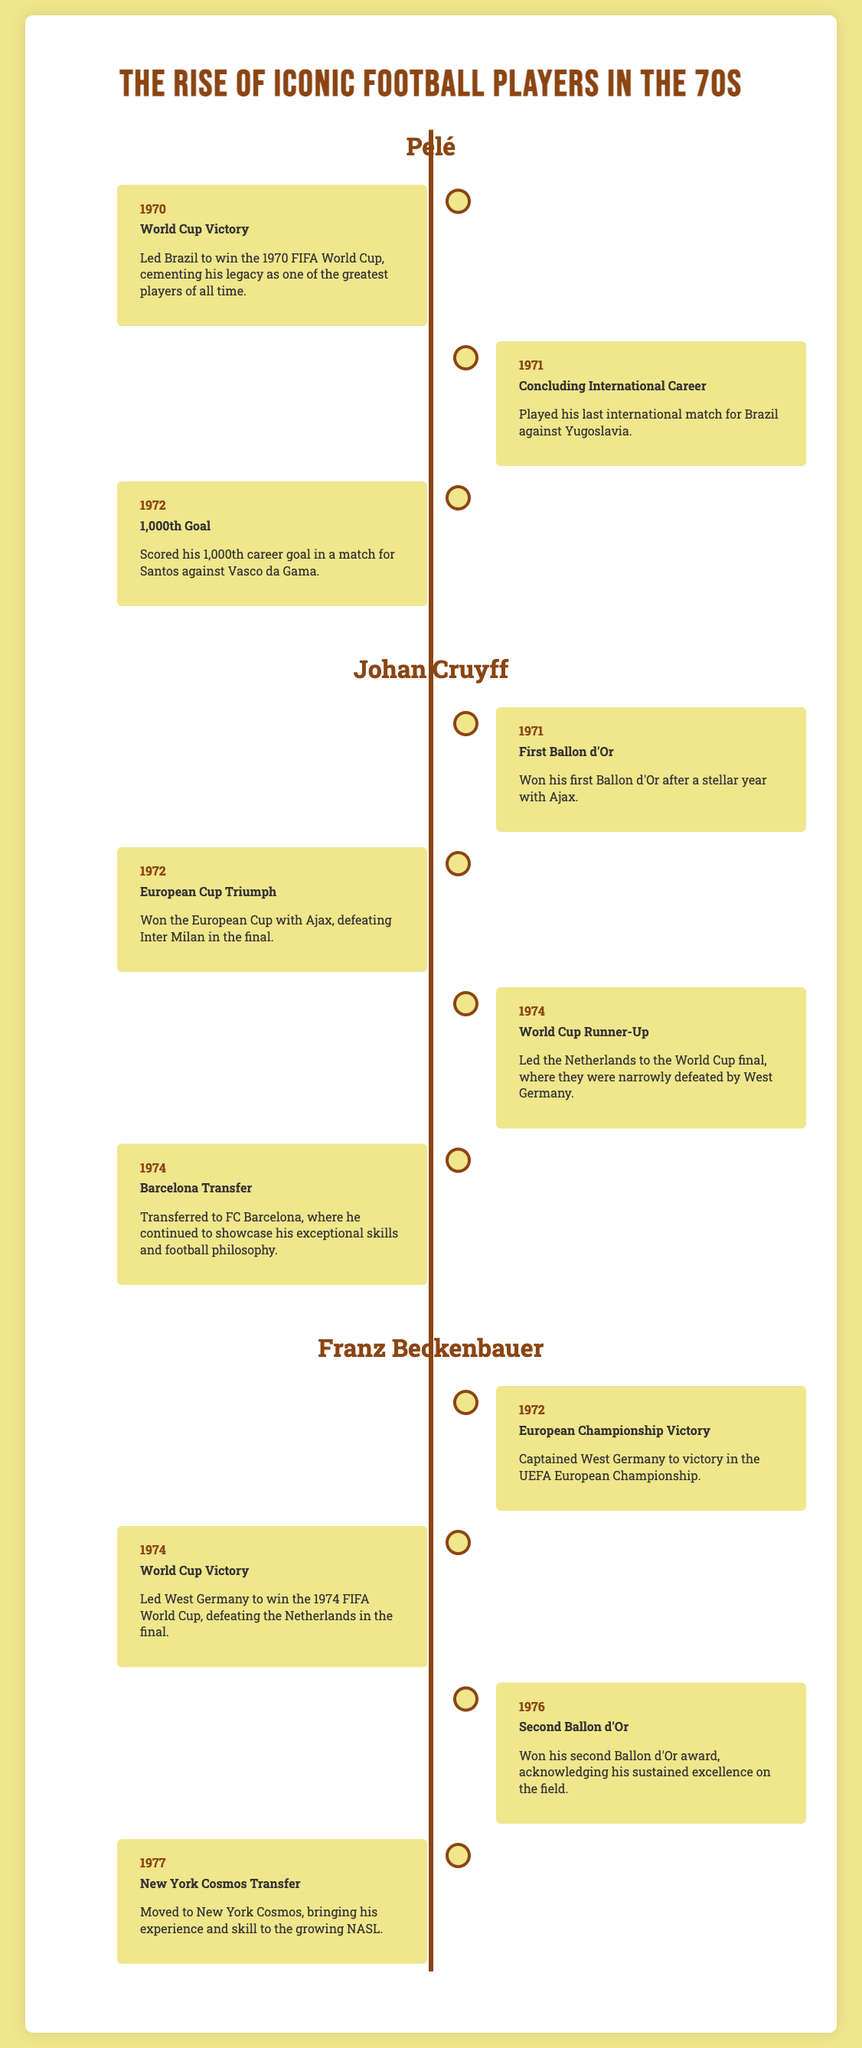What year did Pelé score his 1,000th career goal? The document states Pelé scored his 1,000th career goal in 1972.
Answer: 1972 Who won the Ballon d'Or in 1971? Johan Cruyff is mentioned as having won his first Ballon d'Or in 1971.
Answer: Johan Cruyff Which club did Johan Cruyff transfer to in 1974? The timeline indicates Johan Cruyff transferred to FC Barcelona in 1974.
Answer: FC Barcelona How many Ballon d'Or awards did Franz Beckenbauer win by 1976? The document notes that Franz Beckenbauer won his second Ballon d'Or award in 1976.
Answer: Two What significant achievement did Franz Beckenbauer accomplish in 1974? The document records that he led West Germany to win the 1974 FIFA World Cup.
Answer: World Cup Victory What country did Pelé play his last international match against? The information states that Pelé's last international match was against Yugoslavia.
Answer: Yugoslavia In which year did Johan Cruyff lead the Netherlands to the World Cup final? The document specifies that Johan Cruyff led the Netherlands to the World Cup final in 1974.
Answer: 1974 What was Pelé's last year of international play? The document indicates that Pelé concluded his international career in 1971.
Answer: 1971 What event marked the beginning of Beckenbauer's prominence in European football? The timeline highlights his captaining of West Germany to victory in the UEFA European Championship in 1972.
Answer: European Championship Victory 